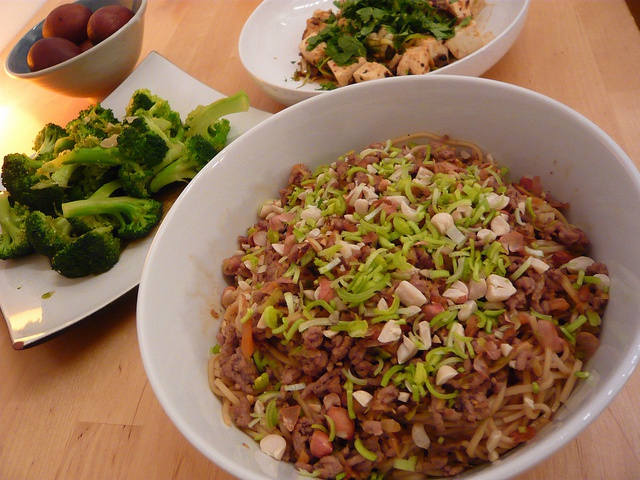Describe the objects in this image and their specific colors. I can see bowl in tan, maroon, gray, brown, and darkgray tones, dining table in tan, salmon, and brown tones, broccoli in tan, black, olive, and darkgreen tones, bowl in tan, lightgray, black, and olive tones, and bowl in tan, maroon, gray, and brown tones in this image. 